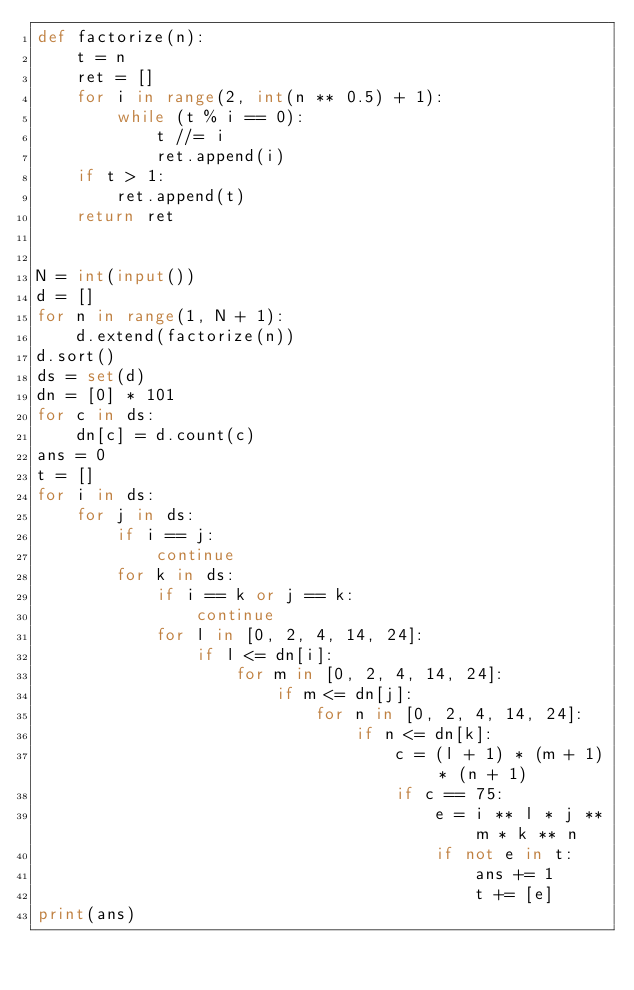<code> <loc_0><loc_0><loc_500><loc_500><_Python_>def factorize(n):
    t = n
    ret = []
    for i in range(2, int(n ** 0.5) + 1):
        while (t % i == 0):
            t //= i
            ret.append(i)
    if t > 1:
        ret.append(t)
    return ret


N = int(input())
d = []
for n in range(1, N + 1):
    d.extend(factorize(n))
d.sort()
ds = set(d)
dn = [0] * 101
for c in ds:
    dn[c] = d.count(c)
ans = 0
t = []
for i in ds:
    for j in ds:
        if i == j:
            continue
        for k in ds:
            if i == k or j == k:
                continue
            for l in [0, 2, 4, 14, 24]:
                if l <= dn[i]:
                    for m in [0, 2, 4, 14, 24]:
                        if m <= dn[j]:
                            for n in [0, 2, 4, 14, 24]:
                                if n <= dn[k]:
                                    c = (l + 1) * (m + 1) * (n + 1)
                                    if c == 75:
                                        e = i ** l * j ** m * k ** n
                                        if not e in t:
                                            ans += 1
                                            t += [e]
print(ans)</code> 